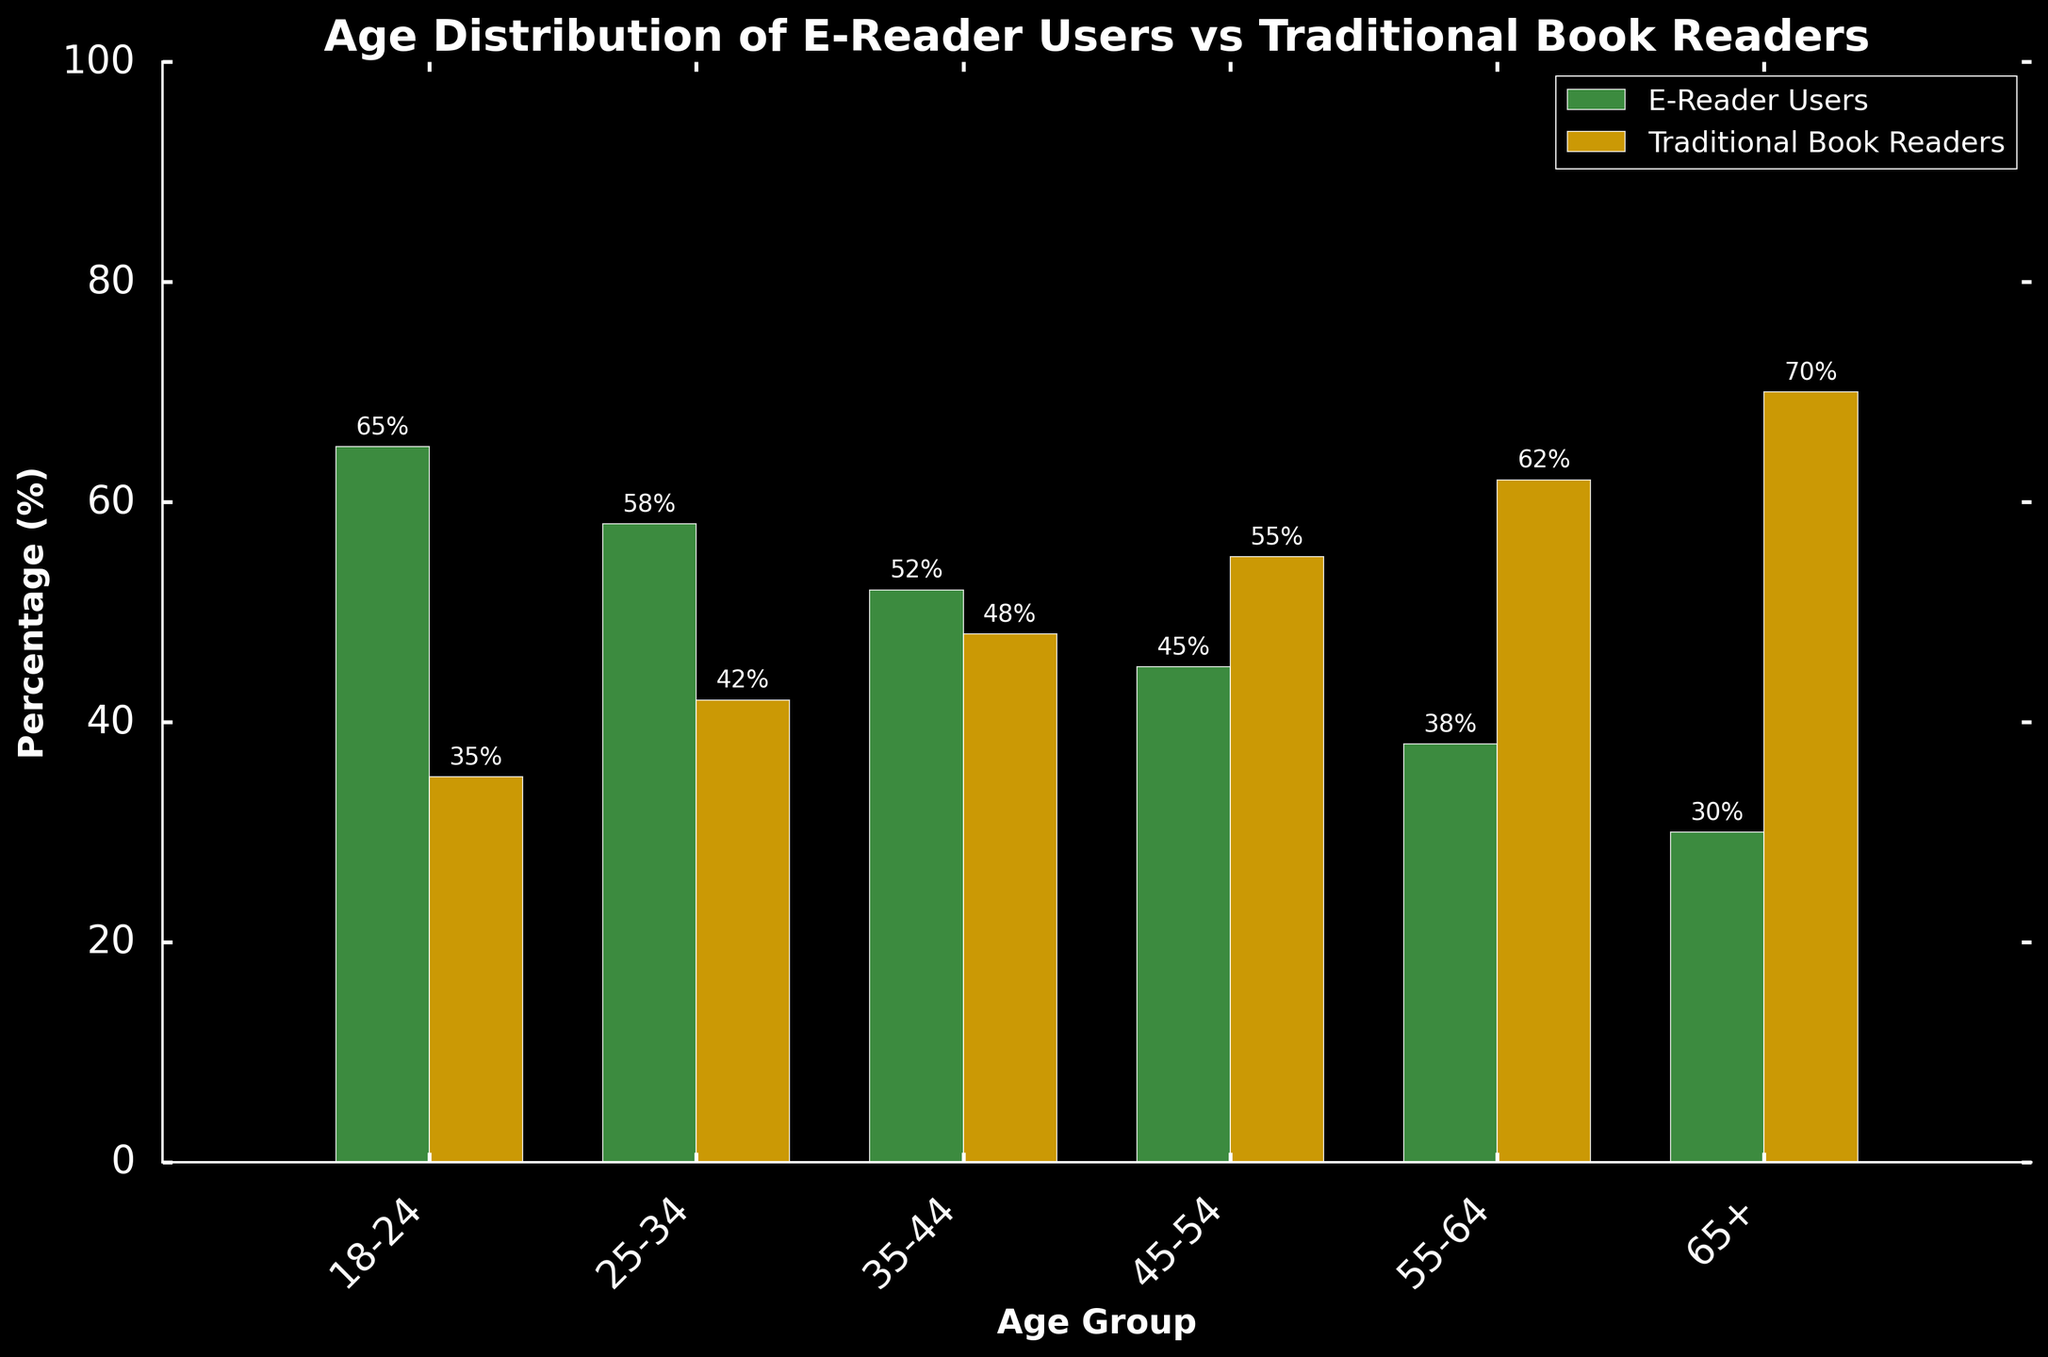What's the percentage of e-reader users in the 18-24 age group? In the bar chart, we can see that the bar representing e-reader users for the 18-24 age group is at 65%.
Answer: 65% Which age group has the highest percentage of traditional book readers? Look for the highest bar for traditional book readers. The 65+ age group shows the highest percentage at 70%.
Answer: 65+ In the 25-34 age group, what is the difference in percentage between e-reader and traditional book readers? Subtract the percentage of traditional book readers from the percentage of e-reader users in the 25-34 age group: 58% - 42% = 16%
Answer: 16% Which age group has an equal or almost equal percentage of e-reader users and traditional book readers? The smallest difference between the bars representing e-reader and traditional book readers is in the 35-44 age group, with percentages of 52% and 48%, respectively.
Answer: 35-44 Between the 55-64 and 65+ age groups, which one has a greater drop in e-reader users compared to the previously younger age group? Examine the drop in percentages: from 45-54 to 55-64, the drop is 7% (45% to 38%), and from 55-64 to 65+, the drop is 8% (38% to 30%).
Answer: 65+ In which age group is the difference between e-reader and traditional book readers the smallest? Calculate the differences for each age group and find the smallest: 18-24 (30%), 25-34 (16%), 35-44 (4%), 45-54 (10%), 55-64 (24%), 65+ (40%). The smallest difference is in the 35-44 age group with 4%.
Answer: 35-44 What is the average percentage of e-reader users across all age groups? Add up the percentages for all age groups and divide by the number of age groups: (65 + 58 + 52 + 45 + 38 + 30) / 6 = 288 / 6 = 48%.
Answer: 48% Which color represents e-reader users, and how can you tell? The e-reader users are represented by green bars. This can be inferred from the legend at the corner of the chart.
Answer: Green For the age group 45-54, how much higher is the percentage of traditional book readers compared to e-reader users? Subtract the e-reader users' percentage from traditional book readers' in the 45-54 age group: 55% - 45% = 10%.
Answer: 10% Do any age groups have the same percentage for e-reader users and traditional book readers? Scan the chart for any bars that are of equal height. None of the age groups have the same percentage for both categories.
Answer: No 